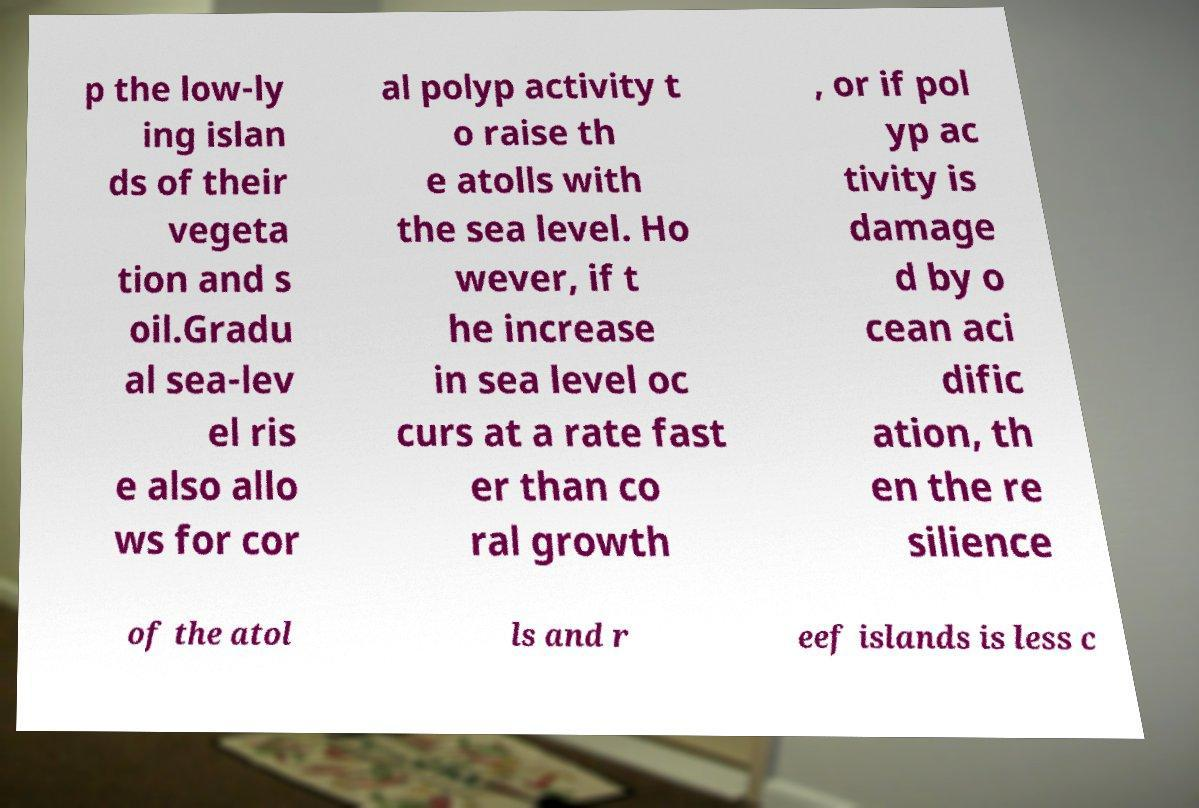Can you accurately transcribe the text from the provided image for me? p the low-ly ing islan ds of their vegeta tion and s oil.Gradu al sea-lev el ris e also allo ws for cor al polyp activity t o raise th e atolls with the sea level. Ho wever, if t he increase in sea level oc curs at a rate fast er than co ral growth , or if pol yp ac tivity is damage d by o cean aci dific ation, th en the re silience of the atol ls and r eef islands is less c 